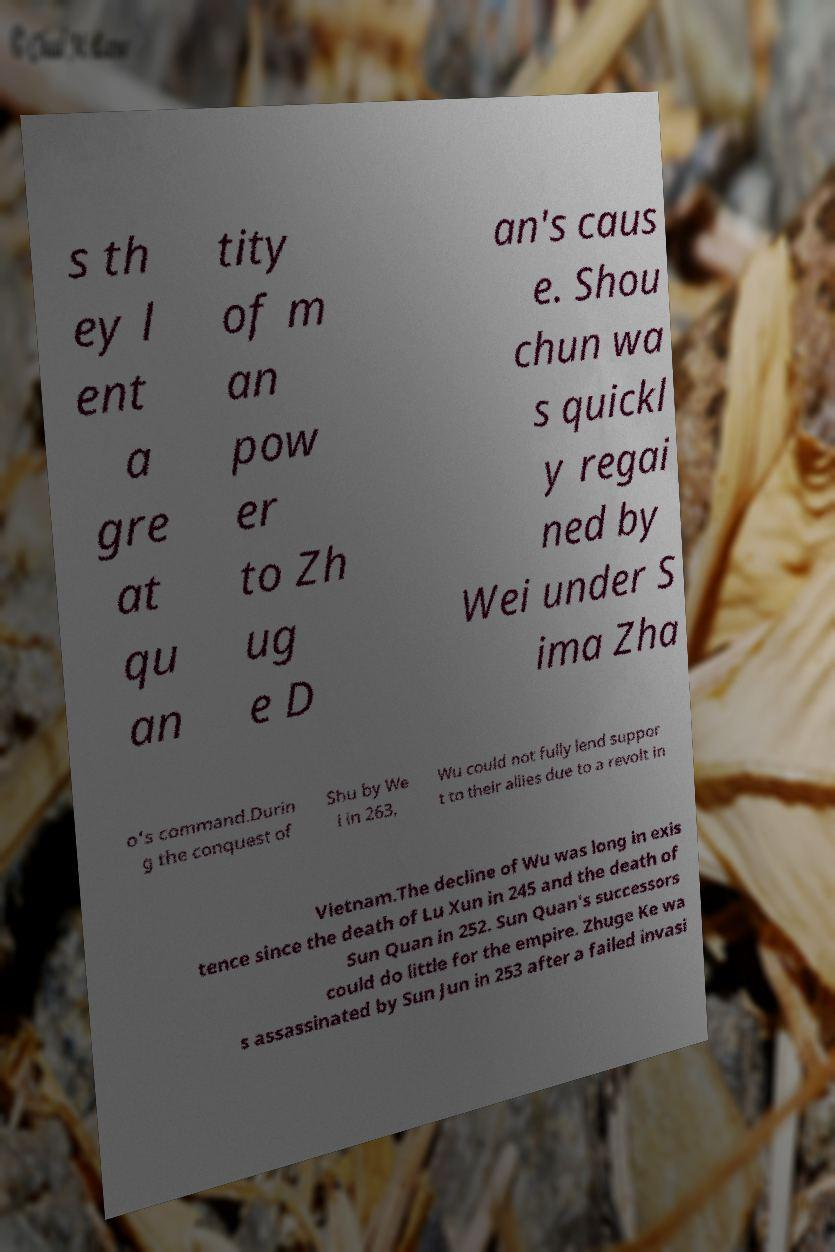Please identify and transcribe the text found in this image. s th ey l ent a gre at qu an tity of m an pow er to Zh ug e D an's caus e. Shou chun wa s quickl y regai ned by Wei under S ima Zha o's command.Durin g the conquest of Shu by We i in 263, Wu could not fully lend suppor t to their allies due to a revolt in Vietnam.The decline of Wu was long in exis tence since the death of Lu Xun in 245 and the death of Sun Quan in 252. Sun Quan's successors could do little for the empire. Zhuge Ke wa s assassinated by Sun Jun in 253 after a failed invasi 